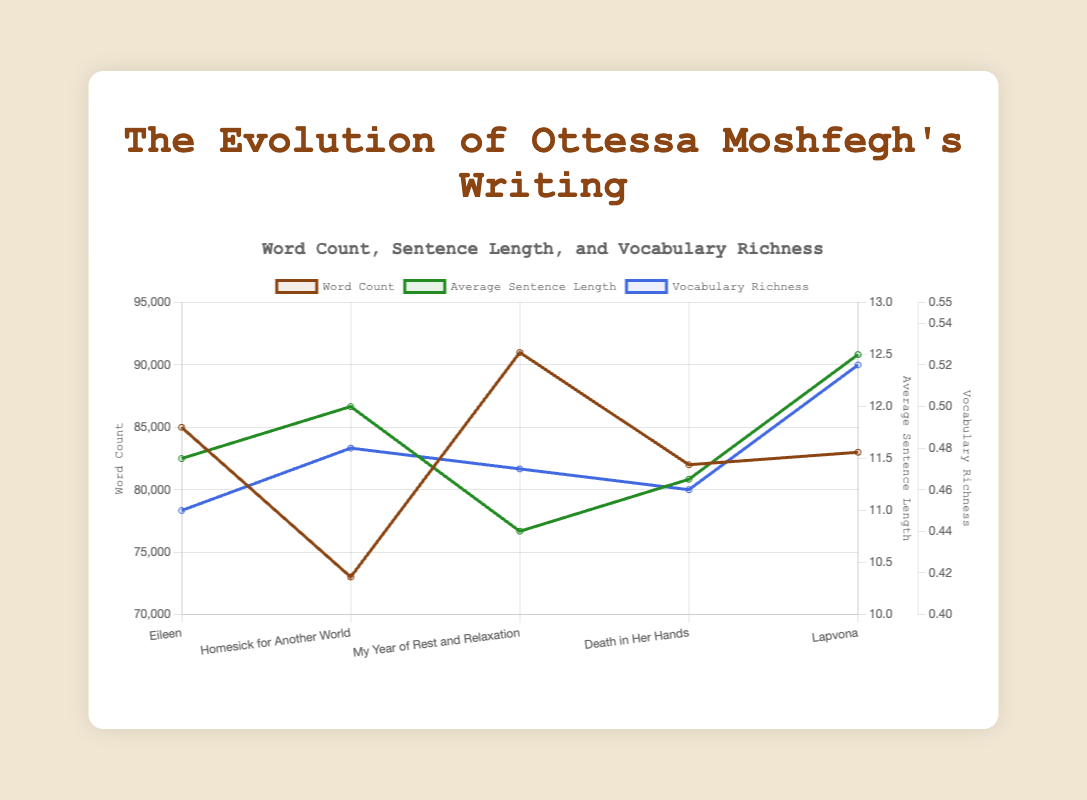Which work has the highest word count? Look at the orange line representing 'Word Count' and find the highest value. 'My Year of Rest and Relaxation' has the highest word count at 91,000.
Answer: 'My Year of Rest and Relaxation' What is the difference in sentence length between 'Homesick for Another World' and 'Lapvona'? Refer to the green line representing 'Average Sentence Length'. 'Homesick for Another World' has 12.0, and 'Lapvona' has 12.5. The difference is 12.5 - 12.0 = 0.5.
Answer: 0.5 Which work has the smallest vocabulary richness? Look at the blue line representing 'Vocabulary Richness'. The lowest value is 0.45, which corresponds to 'Eileen'.
Answer: 'Eileen' List all works in ascending order of their word count. Refer to the orange line to see the word counts for all works and sort them. The order is 'Homesick for Another World' (73,000), 'Death in Her Hands' (82,000), 'Lapvona' (83,000), 'Eileen' (85,000), 'My Year of Rest and Relaxation' (91,000).
Answer: 'Homesick for Another World', 'Death in Her Hands', 'Lapvona', 'Eileen', 'My Year of Rest and Relaxation' Which work experienced the biggest increase in vocabulary richness compared to its predecessor? Compare the increases in the blue line between consecutive works. The largest increase is between 'Death in Her Hands' (0.46) and 'Lapvona' (0.52), which is an increase of 0.52 - 0.46 = 0.06.
Answer: 'Lapvona' What is the average vocabulary richness across all works? Sum the vocabulary richness values (0.45 + 0.48 + 0.47 + 0.46 + 0.52) and divide by the number of works (5). The average is (0.45 + 0.48 + 0.47 + 0.46 + 0.52) / 5 = 0.476.
Answer: 0.476 How did the sentence length change from 'Eileen' to 'My Year of Rest and Relaxation'? Compare the green line values for these two works. 'Eileen' has 11.5, and 'My Year of Rest and Relaxation' has 10.8. The change is 10.8 - 11.5 = -0.7, indicating a decrease.
Answer: Decreased by 0.7 Which work has both the highest word count and the highest vocabulary richness? Look for the highest points on the orange and blue lines. 'My Year of Rest and Relaxation' has the highest word count, and 'Lapvona' has the highest vocabulary richness. No single work has both the highest word count and vocabulary richness.
Answer: None 